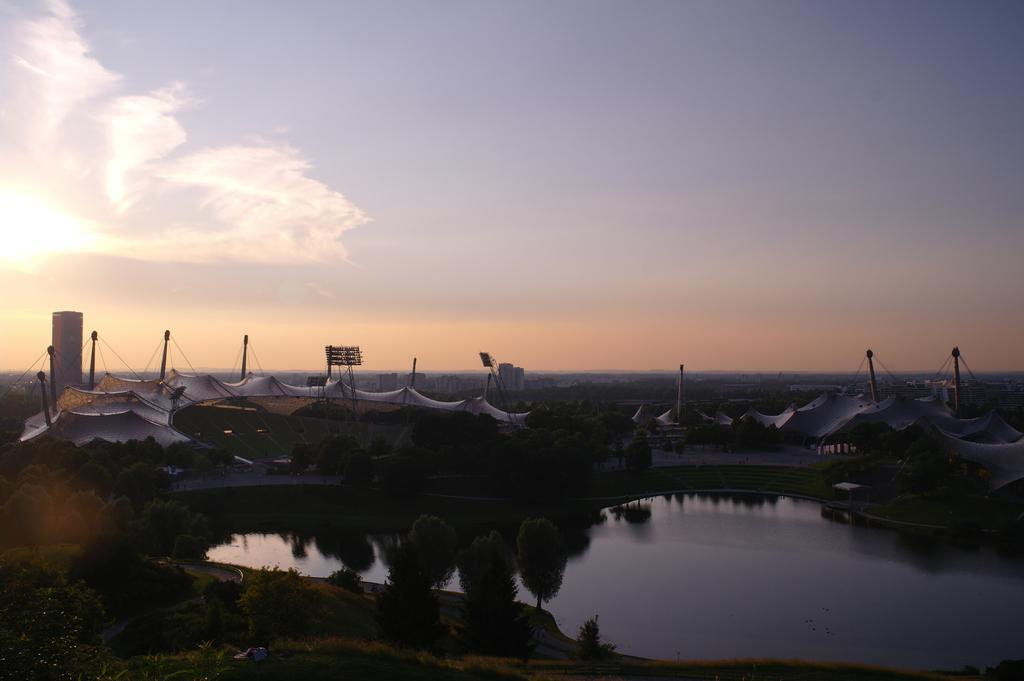In one or two sentences, can you explain what this image depicts? In this image in the center there is one lake and some trees and also we could see some tents, poles, lights and in the background there are some mountains. At the top of the image there is sky. 